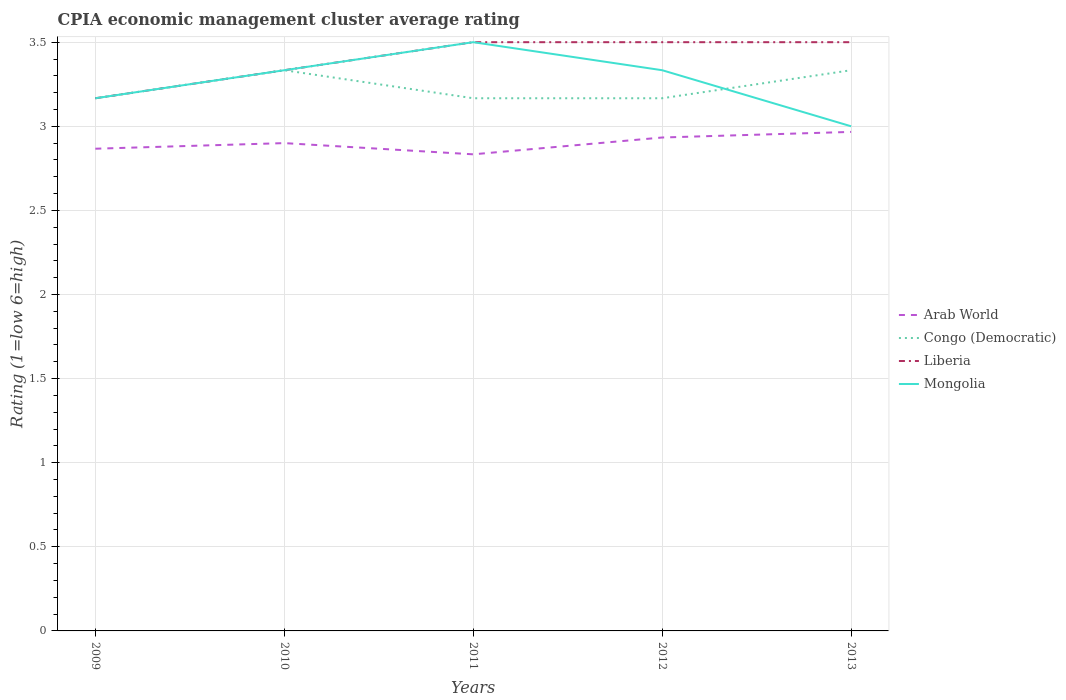Across all years, what is the maximum CPIA rating in Liberia?
Make the answer very short. 3.17. What is the total CPIA rating in Congo (Democratic) in the graph?
Give a very brief answer. 0.17. What is the difference between the highest and the second highest CPIA rating in Liberia?
Your answer should be very brief. 0.33. What is the difference between the highest and the lowest CPIA rating in Arab World?
Provide a succinct answer. 2. How many lines are there?
Your response must be concise. 4. How many years are there in the graph?
Ensure brevity in your answer.  5. What is the difference between two consecutive major ticks on the Y-axis?
Keep it short and to the point. 0.5. Are the values on the major ticks of Y-axis written in scientific E-notation?
Offer a very short reply. No. Does the graph contain grids?
Your answer should be compact. Yes. How many legend labels are there?
Your answer should be compact. 4. How are the legend labels stacked?
Keep it short and to the point. Vertical. What is the title of the graph?
Your answer should be compact. CPIA economic management cluster average rating. What is the label or title of the Y-axis?
Make the answer very short. Rating (1=low 6=high). What is the Rating (1=low 6=high) in Arab World in 2009?
Offer a very short reply. 2.87. What is the Rating (1=low 6=high) in Congo (Democratic) in 2009?
Provide a succinct answer. 3.17. What is the Rating (1=low 6=high) of Liberia in 2009?
Ensure brevity in your answer.  3.17. What is the Rating (1=low 6=high) of Mongolia in 2009?
Provide a short and direct response. 3.17. What is the Rating (1=low 6=high) in Congo (Democratic) in 2010?
Provide a short and direct response. 3.33. What is the Rating (1=low 6=high) in Liberia in 2010?
Make the answer very short. 3.33. What is the Rating (1=low 6=high) of Mongolia in 2010?
Offer a terse response. 3.33. What is the Rating (1=low 6=high) in Arab World in 2011?
Your answer should be compact. 2.83. What is the Rating (1=low 6=high) in Congo (Democratic) in 2011?
Give a very brief answer. 3.17. What is the Rating (1=low 6=high) of Liberia in 2011?
Your response must be concise. 3.5. What is the Rating (1=low 6=high) of Arab World in 2012?
Offer a terse response. 2.93. What is the Rating (1=low 6=high) in Congo (Democratic) in 2012?
Your response must be concise. 3.17. What is the Rating (1=low 6=high) in Liberia in 2012?
Your response must be concise. 3.5. What is the Rating (1=low 6=high) in Mongolia in 2012?
Your answer should be compact. 3.33. What is the Rating (1=low 6=high) of Arab World in 2013?
Your answer should be compact. 2.97. What is the Rating (1=low 6=high) of Congo (Democratic) in 2013?
Your answer should be very brief. 3.33. What is the Rating (1=low 6=high) of Liberia in 2013?
Make the answer very short. 3.5. Across all years, what is the maximum Rating (1=low 6=high) in Arab World?
Your response must be concise. 2.97. Across all years, what is the maximum Rating (1=low 6=high) in Congo (Democratic)?
Your answer should be very brief. 3.33. Across all years, what is the maximum Rating (1=low 6=high) of Liberia?
Ensure brevity in your answer.  3.5. Across all years, what is the maximum Rating (1=low 6=high) of Mongolia?
Provide a succinct answer. 3.5. Across all years, what is the minimum Rating (1=low 6=high) in Arab World?
Offer a very short reply. 2.83. Across all years, what is the minimum Rating (1=low 6=high) of Congo (Democratic)?
Ensure brevity in your answer.  3.17. Across all years, what is the minimum Rating (1=low 6=high) in Liberia?
Your answer should be compact. 3.17. Across all years, what is the minimum Rating (1=low 6=high) of Mongolia?
Provide a short and direct response. 3. What is the total Rating (1=low 6=high) of Congo (Democratic) in the graph?
Give a very brief answer. 16.17. What is the total Rating (1=low 6=high) in Liberia in the graph?
Provide a succinct answer. 17. What is the total Rating (1=low 6=high) of Mongolia in the graph?
Provide a short and direct response. 16.33. What is the difference between the Rating (1=low 6=high) in Arab World in 2009 and that in 2010?
Your response must be concise. -0.03. What is the difference between the Rating (1=low 6=high) of Congo (Democratic) in 2009 and that in 2010?
Provide a short and direct response. -0.17. What is the difference between the Rating (1=low 6=high) in Liberia in 2009 and that in 2010?
Your response must be concise. -0.17. What is the difference between the Rating (1=low 6=high) in Mongolia in 2009 and that in 2010?
Keep it short and to the point. -0.17. What is the difference between the Rating (1=low 6=high) of Congo (Democratic) in 2009 and that in 2011?
Your response must be concise. 0. What is the difference between the Rating (1=low 6=high) of Arab World in 2009 and that in 2012?
Give a very brief answer. -0.07. What is the difference between the Rating (1=low 6=high) of Congo (Democratic) in 2009 and that in 2012?
Offer a terse response. 0. What is the difference between the Rating (1=low 6=high) of Liberia in 2009 and that in 2012?
Provide a succinct answer. -0.33. What is the difference between the Rating (1=low 6=high) in Arab World in 2009 and that in 2013?
Offer a very short reply. -0.1. What is the difference between the Rating (1=low 6=high) of Liberia in 2009 and that in 2013?
Provide a succinct answer. -0.33. What is the difference between the Rating (1=low 6=high) of Mongolia in 2009 and that in 2013?
Ensure brevity in your answer.  0.17. What is the difference between the Rating (1=low 6=high) in Arab World in 2010 and that in 2011?
Keep it short and to the point. 0.07. What is the difference between the Rating (1=low 6=high) in Liberia in 2010 and that in 2011?
Your answer should be compact. -0.17. What is the difference between the Rating (1=low 6=high) of Arab World in 2010 and that in 2012?
Provide a short and direct response. -0.03. What is the difference between the Rating (1=low 6=high) in Arab World in 2010 and that in 2013?
Make the answer very short. -0.07. What is the difference between the Rating (1=low 6=high) in Congo (Democratic) in 2010 and that in 2013?
Offer a terse response. 0. What is the difference between the Rating (1=low 6=high) of Liberia in 2010 and that in 2013?
Your answer should be very brief. -0.17. What is the difference between the Rating (1=low 6=high) in Mongolia in 2010 and that in 2013?
Your answer should be very brief. 0.33. What is the difference between the Rating (1=low 6=high) in Arab World in 2011 and that in 2012?
Offer a terse response. -0.1. What is the difference between the Rating (1=low 6=high) in Liberia in 2011 and that in 2012?
Your response must be concise. 0. What is the difference between the Rating (1=low 6=high) of Mongolia in 2011 and that in 2012?
Make the answer very short. 0.17. What is the difference between the Rating (1=low 6=high) of Arab World in 2011 and that in 2013?
Your answer should be compact. -0.13. What is the difference between the Rating (1=low 6=high) of Congo (Democratic) in 2011 and that in 2013?
Keep it short and to the point. -0.17. What is the difference between the Rating (1=low 6=high) of Liberia in 2011 and that in 2013?
Your answer should be compact. 0. What is the difference between the Rating (1=low 6=high) in Mongolia in 2011 and that in 2013?
Your response must be concise. 0.5. What is the difference between the Rating (1=low 6=high) of Arab World in 2012 and that in 2013?
Your answer should be very brief. -0.03. What is the difference between the Rating (1=low 6=high) in Congo (Democratic) in 2012 and that in 2013?
Offer a very short reply. -0.17. What is the difference between the Rating (1=low 6=high) of Mongolia in 2012 and that in 2013?
Your response must be concise. 0.33. What is the difference between the Rating (1=low 6=high) of Arab World in 2009 and the Rating (1=low 6=high) of Congo (Democratic) in 2010?
Your response must be concise. -0.47. What is the difference between the Rating (1=low 6=high) in Arab World in 2009 and the Rating (1=low 6=high) in Liberia in 2010?
Offer a very short reply. -0.47. What is the difference between the Rating (1=low 6=high) of Arab World in 2009 and the Rating (1=low 6=high) of Mongolia in 2010?
Offer a very short reply. -0.47. What is the difference between the Rating (1=low 6=high) of Congo (Democratic) in 2009 and the Rating (1=low 6=high) of Liberia in 2010?
Your answer should be very brief. -0.17. What is the difference between the Rating (1=low 6=high) in Congo (Democratic) in 2009 and the Rating (1=low 6=high) in Mongolia in 2010?
Offer a very short reply. -0.17. What is the difference between the Rating (1=low 6=high) of Liberia in 2009 and the Rating (1=low 6=high) of Mongolia in 2010?
Your answer should be compact. -0.17. What is the difference between the Rating (1=low 6=high) of Arab World in 2009 and the Rating (1=low 6=high) of Liberia in 2011?
Your response must be concise. -0.63. What is the difference between the Rating (1=low 6=high) in Arab World in 2009 and the Rating (1=low 6=high) in Mongolia in 2011?
Provide a succinct answer. -0.63. What is the difference between the Rating (1=low 6=high) in Liberia in 2009 and the Rating (1=low 6=high) in Mongolia in 2011?
Give a very brief answer. -0.33. What is the difference between the Rating (1=low 6=high) in Arab World in 2009 and the Rating (1=low 6=high) in Liberia in 2012?
Offer a terse response. -0.63. What is the difference between the Rating (1=low 6=high) of Arab World in 2009 and the Rating (1=low 6=high) of Mongolia in 2012?
Offer a very short reply. -0.47. What is the difference between the Rating (1=low 6=high) in Congo (Democratic) in 2009 and the Rating (1=low 6=high) in Mongolia in 2012?
Give a very brief answer. -0.17. What is the difference between the Rating (1=low 6=high) of Arab World in 2009 and the Rating (1=low 6=high) of Congo (Democratic) in 2013?
Your response must be concise. -0.47. What is the difference between the Rating (1=low 6=high) in Arab World in 2009 and the Rating (1=low 6=high) in Liberia in 2013?
Ensure brevity in your answer.  -0.63. What is the difference between the Rating (1=low 6=high) in Arab World in 2009 and the Rating (1=low 6=high) in Mongolia in 2013?
Offer a terse response. -0.13. What is the difference between the Rating (1=low 6=high) of Arab World in 2010 and the Rating (1=low 6=high) of Congo (Democratic) in 2011?
Offer a terse response. -0.27. What is the difference between the Rating (1=low 6=high) in Arab World in 2010 and the Rating (1=low 6=high) in Liberia in 2011?
Ensure brevity in your answer.  -0.6. What is the difference between the Rating (1=low 6=high) of Arab World in 2010 and the Rating (1=low 6=high) of Mongolia in 2011?
Your response must be concise. -0.6. What is the difference between the Rating (1=low 6=high) of Congo (Democratic) in 2010 and the Rating (1=low 6=high) of Liberia in 2011?
Give a very brief answer. -0.17. What is the difference between the Rating (1=low 6=high) of Arab World in 2010 and the Rating (1=low 6=high) of Congo (Democratic) in 2012?
Offer a very short reply. -0.27. What is the difference between the Rating (1=low 6=high) in Arab World in 2010 and the Rating (1=low 6=high) in Mongolia in 2012?
Your answer should be very brief. -0.43. What is the difference between the Rating (1=low 6=high) of Arab World in 2010 and the Rating (1=low 6=high) of Congo (Democratic) in 2013?
Give a very brief answer. -0.43. What is the difference between the Rating (1=low 6=high) of Arab World in 2010 and the Rating (1=low 6=high) of Mongolia in 2013?
Your response must be concise. -0.1. What is the difference between the Rating (1=low 6=high) in Congo (Democratic) in 2010 and the Rating (1=low 6=high) in Liberia in 2013?
Your response must be concise. -0.17. What is the difference between the Rating (1=low 6=high) of Congo (Democratic) in 2010 and the Rating (1=low 6=high) of Mongolia in 2013?
Provide a succinct answer. 0.33. What is the difference between the Rating (1=low 6=high) in Arab World in 2011 and the Rating (1=low 6=high) in Congo (Democratic) in 2012?
Offer a terse response. -0.33. What is the difference between the Rating (1=low 6=high) in Arab World in 2011 and the Rating (1=low 6=high) in Liberia in 2013?
Your response must be concise. -0.67. What is the difference between the Rating (1=low 6=high) in Arab World in 2011 and the Rating (1=low 6=high) in Mongolia in 2013?
Your answer should be very brief. -0.17. What is the difference between the Rating (1=low 6=high) of Congo (Democratic) in 2011 and the Rating (1=low 6=high) of Liberia in 2013?
Offer a very short reply. -0.33. What is the difference between the Rating (1=low 6=high) of Liberia in 2011 and the Rating (1=low 6=high) of Mongolia in 2013?
Your answer should be very brief. 0.5. What is the difference between the Rating (1=low 6=high) of Arab World in 2012 and the Rating (1=low 6=high) of Congo (Democratic) in 2013?
Your answer should be very brief. -0.4. What is the difference between the Rating (1=low 6=high) of Arab World in 2012 and the Rating (1=low 6=high) of Liberia in 2013?
Give a very brief answer. -0.57. What is the difference between the Rating (1=low 6=high) in Arab World in 2012 and the Rating (1=low 6=high) in Mongolia in 2013?
Provide a succinct answer. -0.07. What is the difference between the Rating (1=low 6=high) in Liberia in 2012 and the Rating (1=low 6=high) in Mongolia in 2013?
Offer a terse response. 0.5. What is the average Rating (1=low 6=high) of Arab World per year?
Make the answer very short. 2.9. What is the average Rating (1=low 6=high) in Congo (Democratic) per year?
Offer a terse response. 3.23. What is the average Rating (1=low 6=high) of Mongolia per year?
Ensure brevity in your answer.  3.27. In the year 2009, what is the difference between the Rating (1=low 6=high) of Arab World and Rating (1=low 6=high) of Congo (Democratic)?
Ensure brevity in your answer.  -0.3. In the year 2010, what is the difference between the Rating (1=low 6=high) of Arab World and Rating (1=low 6=high) of Congo (Democratic)?
Offer a terse response. -0.43. In the year 2010, what is the difference between the Rating (1=low 6=high) of Arab World and Rating (1=low 6=high) of Liberia?
Provide a succinct answer. -0.43. In the year 2010, what is the difference between the Rating (1=low 6=high) in Arab World and Rating (1=low 6=high) in Mongolia?
Make the answer very short. -0.43. In the year 2011, what is the difference between the Rating (1=low 6=high) in Arab World and Rating (1=low 6=high) in Congo (Democratic)?
Offer a terse response. -0.33. In the year 2011, what is the difference between the Rating (1=low 6=high) of Liberia and Rating (1=low 6=high) of Mongolia?
Make the answer very short. 0. In the year 2012, what is the difference between the Rating (1=low 6=high) in Arab World and Rating (1=low 6=high) in Congo (Democratic)?
Provide a short and direct response. -0.23. In the year 2012, what is the difference between the Rating (1=low 6=high) in Arab World and Rating (1=low 6=high) in Liberia?
Offer a terse response. -0.57. In the year 2012, what is the difference between the Rating (1=low 6=high) of Liberia and Rating (1=low 6=high) of Mongolia?
Your response must be concise. 0.17. In the year 2013, what is the difference between the Rating (1=low 6=high) in Arab World and Rating (1=low 6=high) in Congo (Democratic)?
Your response must be concise. -0.37. In the year 2013, what is the difference between the Rating (1=low 6=high) in Arab World and Rating (1=low 6=high) in Liberia?
Offer a very short reply. -0.53. In the year 2013, what is the difference between the Rating (1=low 6=high) in Arab World and Rating (1=low 6=high) in Mongolia?
Make the answer very short. -0.03. In the year 2013, what is the difference between the Rating (1=low 6=high) of Liberia and Rating (1=low 6=high) of Mongolia?
Give a very brief answer. 0.5. What is the ratio of the Rating (1=low 6=high) in Arab World in 2009 to that in 2011?
Keep it short and to the point. 1.01. What is the ratio of the Rating (1=low 6=high) in Congo (Democratic) in 2009 to that in 2011?
Make the answer very short. 1. What is the ratio of the Rating (1=low 6=high) of Liberia in 2009 to that in 2011?
Make the answer very short. 0.9. What is the ratio of the Rating (1=low 6=high) of Mongolia in 2009 to that in 2011?
Your answer should be compact. 0.9. What is the ratio of the Rating (1=low 6=high) of Arab World in 2009 to that in 2012?
Your answer should be very brief. 0.98. What is the ratio of the Rating (1=low 6=high) of Liberia in 2009 to that in 2012?
Make the answer very short. 0.9. What is the ratio of the Rating (1=low 6=high) of Mongolia in 2009 to that in 2012?
Keep it short and to the point. 0.95. What is the ratio of the Rating (1=low 6=high) of Arab World in 2009 to that in 2013?
Provide a short and direct response. 0.97. What is the ratio of the Rating (1=low 6=high) in Congo (Democratic) in 2009 to that in 2013?
Offer a very short reply. 0.95. What is the ratio of the Rating (1=low 6=high) of Liberia in 2009 to that in 2013?
Offer a terse response. 0.9. What is the ratio of the Rating (1=low 6=high) in Mongolia in 2009 to that in 2013?
Make the answer very short. 1.06. What is the ratio of the Rating (1=low 6=high) in Arab World in 2010 to that in 2011?
Provide a succinct answer. 1.02. What is the ratio of the Rating (1=low 6=high) of Congo (Democratic) in 2010 to that in 2011?
Give a very brief answer. 1.05. What is the ratio of the Rating (1=low 6=high) of Liberia in 2010 to that in 2011?
Your response must be concise. 0.95. What is the ratio of the Rating (1=low 6=high) of Mongolia in 2010 to that in 2011?
Ensure brevity in your answer.  0.95. What is the ratio of the Rating (1=low 6=high) in Arab World in 2010 to that in 2012?
Make the answer very short. 0.99. What is the ratio of the Rating (1=low 6=high) in Congo (Democratic) in 2010 to that in 2012?
Ensure brevity in your answer.  1.05. What is the ratio of the Rating (1=low 6=high) of Mongolia in 2010 to that in 2012?
Make the answer very short. 1. What is the ratio of the Rating (1=low 6=high) in Arab World in 2010 to that in 2013?
Ensure brevity in your answer.  0.98. What is the ratio of the Rating (1=low 6=high) in Congo (Democratic) in 2010 to that in 2013?
Keep it short and to the point. 1. What is the ratio of the Rating (1=low 6=high) of Liberia in 2010 to that in 2013?
Your response must be concise. 0.95. What is the ratio of the Rating (1=low 6=high) in Mongolia in 2010 to that in 2013?
Provide a short and direct response. 1.11. What is the ratio of the Rating (1=low 6=high) of Arab World in 2011 to that in 2012?
Make the answer very short. 0.97. What is the ratio of the Rating (1=low 6=high) in Congo (Democratic) in 2011 to that in 2012?
Your answer should be very brief. 1. What is the ratio of the Rating (1=low 6=high) in Mongolia in 2011 to that in 2012?
Provide a succinct answer. 1.05. What is the ratio of the Rating (1=low 6=high) of Arab World in 2011 to that in 2013?
Keep it short and to the point. 0.96. What is the ratio of the Rating (1=low 6=high) in Congo (Democratic) in 2011 to that in 2013?
Your response must be concise. 0.95. What is the ratio of the Rating (1=low 6=high) of Arab World in 2012 to that in 2013?
Ensure brevity in your answer.  0.99. What is the difference between the highest and the lowest Rating (1=low 6=high) in Arab World?
Give a very brief answer. 0.13. What is the difference between the highest and the lowest Rating (1=low 6=high) in Congo (Democratic)?
Your response must be concise. 0.17. 